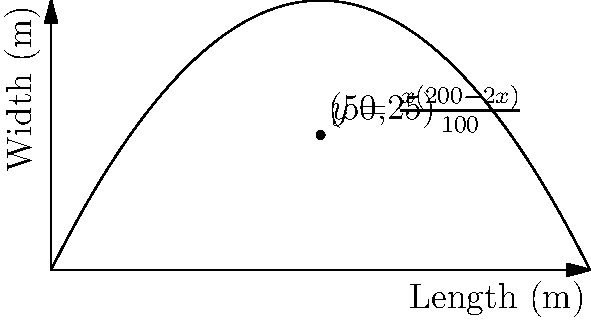An Ethiopian coffee plantation is being planned on a rectangular plot of land. The total perimeter of the plot is 200 meters. If $x$ represents the length of the plot in meters, express the width $y$ in terms of $x$. Then, find the dimensions that will maximize the area of the plantation. Round your answer to the nearest meter. Let's approach this step-by-step:

1) Given that the perimeter is 200 meters, we can express this as:
   $2x + 2y = 200$

2) Solving for $y$:
   $y = 100 - x$

3) The area $A$ of the rectangle is given by $A = xy$. Substituting our expression for $y$:
   $A = x(100-x) = 100x - x^2$

4) To find the maximum area, we need to find where the derivative of $A$ with respect to $x$ is zero:
   $\frac{dA}{dx} = 100 - 2x$

5) Setting this equal to zero:
   $100 - 2x = 0$
   $2x = 100$
   $x = 50$

6) To confirm this is a maximum, we can check the second derivative:
   $\frac{d^2A}{dx^2} = -2$, which is negative, confirming a maximum.

7) When $x = 50$, $y = 100 - 50 = 50$

Therefore, the dimensions that maximize the area are 50 meters by 50 meters.
Answer: 50 m × 50 m 